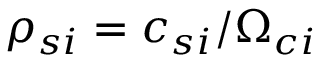Convert formula to latex. <formula><loc_0><loc_0><loc_500><loc_500>\rho _ { s i } = c _ { s i } / \Omega _ { c i }</formula> 